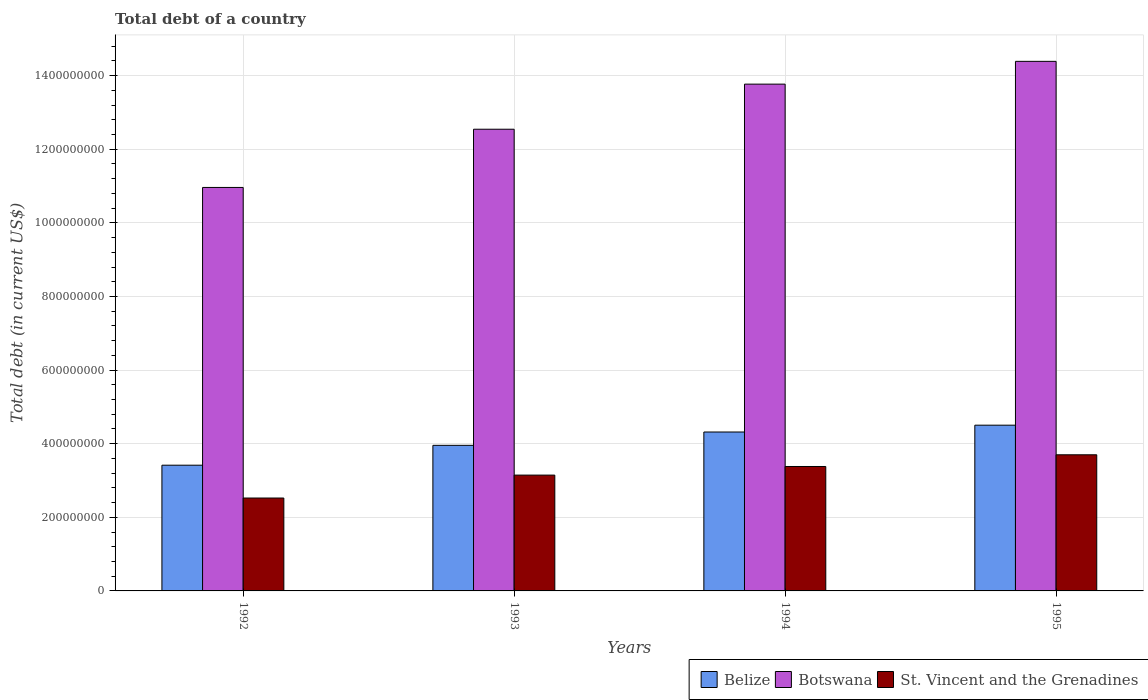How many groups of bars are there?
Make the answer very short. 4. How many bars are there on the 4th tick from the right?
Offer a very short reply. 3. What is the label of the 4th group of bars from the left?
Keep it short and to the point. 1995. What is the debt in Botswana in 1994?
Your answer should be very brief. 1.38e+09. Across all years, what is the maximum debt in Belize?
Keep it short and to the point. 4.50e+08. Across all years, what is the minimum debt in Belize?
Your answer should be very brief. 3.42e+08. In which year was the debt in St. Vincent and the Grenadines maximum?
Make the answer very short. 1995. What is the total debt in Belize in the graph?
Offer a very short reply. 1.62e+09. What is the difference between the debt in Botswana in 1992 and that in 1994?
Your answer should be compact. -2.81e+08. What is the difference between the debt in Belize in 1992 and the debt in Botswana in 1993?
Make the answer very short. -9.13e+08. What is the average debt in St. Vincent and the Grenadines per year?
Offer a very short reply. 3.19e+08. In the year 1995, what is the difference between the debt in Botswana and debt in St. Vincent and the Grenadines?
Offer a terse response. 1.07e+09. What is the ratio of the debt in Botswana in 1992 to that in 1993?
Offer a very short reply. 0.87. Is the debt in Belize in 1993 less than that in 1995?
Provide a short and direct response. Yes. What is the difference between the highest and the second highest debt in Botswana?
Provide a succinct answer. 6.19e+07. What is the difference between the highest and the lowest debt in St. Vincent and the Grenadines?
Ensure brevity in your answer.  1.18e+08. In how many years, is the debt in Belize greater than the average debt in Belize taken over all years?
Your response must be concise. 2. What does the 2nd bar from the left in 1993 represents?
Keep it short and to the point. Botswana. What does the 2nd bar from the right in 1992 represents?
Offer a terse response. Botswana. How many years are there in the graph?
Your response must be concise. 4. Are the values on the major ticks of Y-axis written in scientific E-notation?
Provide a succinct answer. No. Does the graph contain grids?
Provide a succinct answer. Yes. What is the title of the graph?
Provide a short and direct response. Total debt of a country. What is the label or title of the Y-axis?
Offer a terse response. Total debt (in current US$). What is the Total debt (in current US$) in Belize in 1992?
Make the answer very short. 3.42e+08. What is the Total debt (in current US$) of Botswana in 1992?
Provide a short and direct response. 1.10e+09. What is the Total debt (in current US$) in St. Vincent and the Grenadines in 1992?
Give a very brief answer. 2.52e+08. What is the Total debt (in current US$) of Belize in 1993?
Ensure brevity in your answer.  3.96e+08. What is the Total debt (in current US$) in Botswana in 1993?
Your answer should be compact. 1.25e+09. What is the Total debt (in current US$) in St. Vincent and the Grenadines in 1993?
Provide a short and direct response. 3.15e+08. What is the Total debt (in current US$) in Belize in 1994?
Your answer should be compact. 4.32e+08. What is the Total debt (in current US$) in Botswana in 1994?
Give a very brief answer. 1.38e+09. What is the Total debt (in current US$) in St. Vincent and the Grenadines in 1994?
Keep it short and to the point. 3.38e+08. What is the Total debt (in current US$) of Belize in 1995?
Provide a succinct answer. 4.50e+08. What is the Total debt (in current US$) of Botswana in 1995?
Offer a very short reply. 1.44e+09. What is the Total debt (in current US$) in St. Vincent and the Grenadines in 1995?
Keep it short and to the point. 3.70e+08. Across all years, what is the maximum Total debt (in current US$) in Belize?
Your answer should be compact. 4.50e+08. Across all years, what is the maximum Total debt (in current US$) in Botswana?
Your response must be concise. 1.44e+09. Across all years, what is the maximum Total debt (in current US$) of St. Vincent and the Grenadines?
Your answer should be compact. 3.70e+08. Across all years, what is the minimum Total debt (in current US$) of Belize?
Provide a succinct answer. 3.42e+08. Across all years, what is the minimum Total debt (in current US$) of Botswana?
Offer a very short reply. 1.10e+09. Across all years, what is the minimum Total debt (in current US$) in St. Vincent and the Grenadines?
Provide a short and direct response. 2.52e+08. What is the total Total debt (in current US$) in Belize in the graph?
Keep it short and to the point. 1.62e+09. What is the total Total debt (in current US$) of Botswana in the graph?
Ensure brevity in your answer.  5.17e+09. What is the total Total debt (in current US$) of St. Vincent and the Grenadines in the graph?
Provide a succinct answer. 1.28e+09. What is the difference between the Total debt (in current US$) in Belize in 1992 and that in 1993?
Keep it short and to the point. -5.39e+07. What is the difference between the Total debt (in current US$) in Botswana in 1992 and that in 1993?
Provide a succinct answer. -1.58e+08. What is the difference between the Total debt (in current US$) in St. Vincent and the Grenadines in 1992 and that in 1993?
Your answer should be very brief. -6.23e+07. What is the difference between the Total debt (in current US$) in Belize in 1992 and that in 1994?
Give a very brief answer. -9.02e+07. What is the difference between the Total debt (in current US$) of Botswana in 1992 and that in 1994?
Keep it short and to the point. -2.81e+08. What is the difference between the Total debt (in current US$) of St. Vincent and the Grenadines in 1992 and that in 1994?
Offer a terse response. -8.57e+07. What is the difference between the Total debt (in current US$) of Belize in 1992 and that in 1995?
Offer a terse response. -1.09e+08. What is the difference between the Total debt (in current US$) in Botswana in 1992 and that in 1995?
Your answer should be compact. -3.43e+08. What is the difference between the Total debt (in current US$) in St. Vincent and the Grenadines in 1992 and that in 1995?
Ensure brevity in your answer.  -1.18e+08. What is the difference between the Total debt (in current US$) of Belize in 1993 and that in 1994?
Keep it short and to the point. -3.62e+07. What is the difference between the Total debt (in current US$) in Botswana in 1993 and that in 1994?
Your response must be concise. -1.22e+08. What is the difference between the Total debt (in current US$) in St. Vincent and the Grenadines in 1993 and that in 1994?
Provide a succinct answer. -2.34e+07. What is the difference between the Total debt (in current US$) of Belize in 1993 and that in 1995?
Ensure brevity in your answer.  -5.48e+07. What is the difference between the Total debt (in current US$) in Botswana in 1993 and that in 1995?
Your response must be concise. -1.84e+08. What is the difference between the Total debt (in current US$) of St. Vincent and the Grenadines in 1993 and that in 1995?
Give a very brief answer. -5.52e+07. What is the difference between the Total debt (in current US$) of Belize in 1994 and that in 1995?
Give a very brief answer. -1.86e+07. What is the difference between the Total debt (in current US$) in Botswana in 1994 and that in 1995?
Offer a very short reply. -6.19e+07. What is the difference between the Total debt (in current US$) in St. Vincent and the Grenadines in 1994 and that in 1995?
Keep it short and to the point. -3.18e+07. What is the difference between the Total debt (in current US$) of Belize in 1992 and the Total debt (in current US$) of Botswana in 1993?
Your answer should be compact. -9.13e+08. What is the difference between the Total debt (in current US$) of Belize in 1992 and the Total debt (in current US$) of St. Vincent and the Grenadines in 1993?
Your answer should be compact. 2.69e+07. What is the difference between the Total debt (in current US$) of Botswana in 1992 and the Total debt (in current US$) of St. Vincent and the Grenadines in 1993?
Offer a very short reply. 7.82e+08. What is the difference between the Total debt (in current US$) in Belize in 1992 and the Total debt (in current US$) in Botswana in 1994?
Your answer should be compact. -1.04e+09. What is the difference between the Total debt (in current US$) of Belize in 1992 and the Total debt (in current US$) of St. Vincent and the Grenadines in 1994?
Give a very brief answer. 3.52e+06. What is the difference between the Total debt (in current US$) in Botswana in 1992 and the Total debt (in current US$) in St. Vincent and the Grenadines in 1994?
Provide a succinct answer. 7.58e+08. What is the difference between the Total debt (in current US$) of Belize in 1992 and the Total debt (in current US$) of Botswana in 1995?
Your answer should be compact. -1.10e+09. What is the difference between the Total debt (in current US$) in Belize in 1992 and the Total debt (in current US$) in St. Vincent and the Grenadines in 1995?
Your response must be concise. -2.83e+07. What is the difference between the Total debt (in current US$) of Botswana in 1992 and the Total debt (in current US$) of St. Vincent and the Grenadines in 1995?
Give a very brief answer. 7.26e+08. What is the difference between the Total debt (in current US$) of Belize in 1993 and the Total debt (in current US$) of Botswana in 1994?
Make the answer very short. -9.81e+08. What is the difference between the Total debt (in current US$) in Belize in 1993 and the Total debt (in current US$) in St. Vincent and the Grenadines in 1994?
Offer a very short reply. 5.75e+07. What is the difference between the Total debt (in current US$) in Botswana in 1993 and the Total debt (in current US$) in St. Vincent and the Grenadines in 1994?
Provide a succinct answer. 9.16e+08. What is the difference between the Total debt (in current US$) of Belize in 1993 and the Total debt (in current US$) of Botswana in 1995?
Ensure brevity in your answer.  -1.04e+09. What is the difference between the Total debt (in current US$) of Belize in 1993 and the Total debt (in current US$) of St. Vincent and the Grenadines in 1995?
Make the answer very short. 2.57e+07. What is the difference between the Total debt (in current US$) in Botswana in 1993 and the Total debt (in current US$) in St. Vincent and the Grenadines in 1995?
Offer a very short reply. 8.85e+08. What is the difference between the Total debt (in current US$) in Belize in 1994 and the Total debt (in current US$) in Botswana in 1995?
Your answer should be very brief. -1.01e+09. What is the difference between the Total debt (in current US$) in Belize in 1994 and the Total debt (in current US$) in St. Vincent and the Grenadines in 1995?
Provide a succinct answer. 6.19e+07. What is the difference between the Total debt (in current US$) in Botswana in 1994 and the Total debt (in current US$) in St. Vincent and the Grenadines in 1995?
Your answer should be very brief. 1.01e+09. What is the average Total debt (in current US$) of Belize per year?
Offer a terse response. 4.05e+08. What is the average Total debt (in current US$) in Botswana per year?
Give a very brief answer. 1.29e+09. What is the average Total debt (in current US$) of St. Vincent and the Grenadines per year?
Offer a very short reply. 3.19e+08. In the year 1992, what is the difference between the Total debt (in current US$) in Belize and Total debt (in current US$) in Botswana?
Offer a terse response. -7.55e+08. In the year 1992, what is the difference between the Total debt (in current US$) in Belize and Total debt (in current US$) in St. Vincent and the Grenadines?
Your response must be concise. 8.92e+07. In the year 1992, what is the difference between the Total debt (in current US$) of Botswana and Total debt (in current US$) of St. Vincent and the Grenadines?
Keep it short and to the point. 8.44e+08. In the year 1993, what is the difference between the Total debt (in current US$) of Belize and Total debt (in current US$) of Botswana?
Your answer should be compact. -8.59e+08. In the year 1993, what is the difference between the Total debt (in current US$) of Belize and Total debt (in current US$) of St. Vincent and the Grenadines?
Ensure brevity in your answer.  8.09e+07. In the year 1993, what is the difference between the Total debt (in current US$) of Botswana and Total debt (in current US$) of St. Vincent and the Grenadines?
Your response must be concise. 9.40e+08. In the year 1994, what is the difference between the Total debt (in current US$) in Belize and Total debt (in current US$) in Botswana?
Offer a very short reply. -9.45e+08. In the year 1994, what is the difference between the Total debt (in current US$) of Belize and Total debt (in current US$) of St. Vincent and the Grenadines?
Keep it short and to the point. 9.37e+07. In the year 1994, what is the difference between the Total debt (in current US$) of Botswana and Total debt (in current US$) of St. Vincent and the Grenadines?
Offer a terse response. 1.04e+09. In the year 1995, what is the difference between the Total debt (in current US$) in Belize and Total debt (in current US$) in Botswana?
Provide a short and direct response. -9.89e+08. In the year 1995, what is the difference between the Total debt (in current US$) in Belize and Total debt (in current US$) in St. Vincent and the Grenadines?
Give a very brief answer. 8.05e+07. In the year 1995, what is the difference between the Total debt (in current US$) of Botswana and Total debt (in current US$) of St. Vincent and the Grenadines?
Your response must be concise. 1.07e+09. What is the ratio of the Total debt (in current US$) in Belize in 1992 to that in 1993?
Make the answer very short. 0.86. What is the ratio of the Total debt (in current US$) of Botswana in 1992 to that in 1993?
Give a very brief answer. 0.87. What is the ratio of the Total debt (in current US$) of St. Vincent and the Grenadines in 1992 to that in 1993?
Ensure brevity in your answer.  0.8. What is the ratio of the Total debt (in current US$) of Belize in 1992 to that in 1994?
Your response must be concise. 0.79. What is the ratio of the Total debt (in current US$) of Botswana in 1992 to that in 1994?
Offer a very short reply. 0.8. What is the ratio of the Total debt (in current US$) of St. Vincent and the Grenadines in 1992 to that in 1994?
Provide a short and direct response. 0.75. What is the ratio of the Total debt (in current US$) of Belize in 1992 to that in 1995?
Provide a succinct answer. 0.76. What is the ratio of the Total debt (in current US$) of Botswana in 1992 to that in 1995?
Provide a short and direct response. 0.76. What is the ratio of the Total debt (in current US$) of St. Vincent and the Grenadines in 1992 to that in 1995?
Offer a very short reply. 0.68. What is the ratio of the Total debt (in current US$) of Belize in 1993 to that in 1994?
Ensure brevity in your answer.  0.92. What is the ratio of the Total debt (in current US$) in Botswana in 1993 to that in 1994?
Keep it short and to the point. 0.91. What is the ratio of the Total debt (in current US$) of St. Vincent and the Grenadines in 1993 to that in 1994?
Provide a succinct answer. 0.93. What is the ratio of the Total debt (in current US$) of Belize in 1993 to that in 1995?
Provide a short and direct response. 0.88. What is the ratio of the Total debt (in current US$) in Botswana in 1993 to that in 1995?
Ensure brevity in your answer.  0.87. What is the ratio of the Total debt (in current US$) in St. Vincent and the Grenadines in 1993 to that in 1995?
Your answer should be compact. 0.85. What is the ratio of the Total debt (in current US$) of Belize in 1994 to that in 1995?
Ensure brevity in your answer.  0.96. What is the ratio of the Total debt (in current US$) of Botswana in 1994 to that in 1995?
Provide a succinct answer. 0.96. What is the ratio of the Total debt (in current US$) in St. Vincent and the Grenadines in 1994 to that in 1995?
Your answer should be compact. 0.91. What is the difference between the highest and the second highest Total debt (in current US$) of Belize?
Provide a short and direct response. 1.86e+07. What is the difference between the highest and the second highest Total debt (in current US$) of Botswana?
Make the answer very short. 6.19e+07. What is the difference between the highest and the second highest Total debt (in current US$) in St. Vincent and the Grenadines?
Make the answer very short. 3.18e+07. What is the difference between the highest and the lowest Total debt (in current US$) in Belize?
Give a very brief answer. 1.09e+08. What is the difference between the highest and the lowest Total debt (in current US$) of Botswana?
Provide a succinct answer. 3.43e+08. What is the difference between the highest and the lowest Total debt (in current US$) of St. Vincent and the Grenadines?
Your answer should be compact. 1.18e+08. 